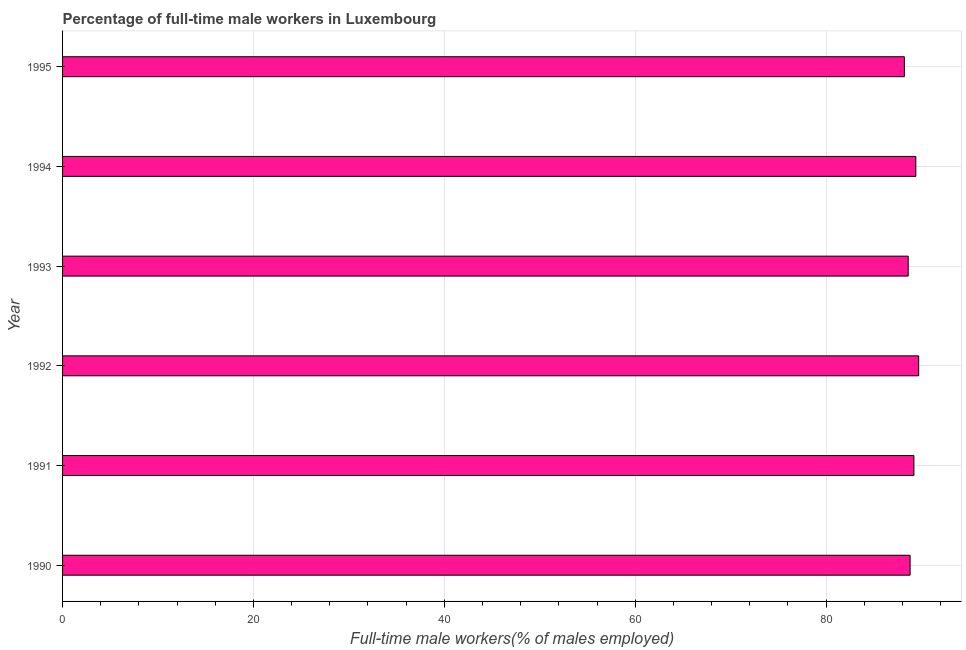Does the graph contain any zero values?
Keep it short and to the point. No. What is the title of the graph?
Offer a terse response. Percentage of full-time male workers in Luxembourg. What is the label or title of the X-axis?
Your response must be concise. Full-time male workers(% of males employed). What is the label or title of the Y-axis?
Give a very brief answer. Year. What is the percentage of full-time male workers in 1993?
Provide a short and direct response. 88.6. Across all years, what is the maximum percentage of full-time male workers?
Your response must be concise. 89.7. Across all years, what is the minimum percentage of full-time male workers?
Your answer should be compact. 88.2. In which year was the percentage of full-time male workers maximum?
Offer a terse response. 1992. What is the sum of the percentage of full-time male workers?
Provide a succinct answer. 533.9. What is the difference between the percentage of full-time male workers in 1990 and 1992?
Ensure brevity in your answer.  -0.9. What is the average percentage of full-time male workers per year?
Provide a short and direct response. 88.98. What is the median percentage of full-time male workers?
Your answer should be very brief. 89. In how many years, is the percentage of full-time male workers greater than 56 %?
Offer a terse response. 6. Do a majority of the years between 1995 and 1994 (inclusive) have percentage of full-time male workers greater than 64 %?
Make the answer very short. No. What is the ratio of the percentage of full-time male workers in 1990 to that in 1992?
Your response must be concise. 0.99. Is the percentage of full-time male workers in 1992 less than that in 1995?
Keep it short and to the point. No. Is the sum of the percentage of full-time male workers in 1990 and 1994 greater than the maximum percentage of full-time male workers across all years?
Your answer should be compact. Yes. What is the difference between the highest and the lowest percentage of full-time male workers?
Offer a terse response. 1.5. In how many years, is the percentage of full-time male workers greater than the average percentage of full-time male workers taken over all years?
Offer a very short reply. 3. What is the difference between two consecutive major ticks on the X-axis?
Give a very brief answer. 20. Are the values on the major ticks of X-axis written in scientific E-notation?
Your answer should be compact. No. What is the Full-time male workers(% of males employed) in 1990?
Make the answer very short. 88.8. What is the Full-time male workers(% of males employed) of 1991?
Your answer should be compact. 89.2. What is the Full-time male workers(% of males employed) of 1992?
Give a very brief answer. 89.7. What is the Full-time male workers(% of males employed) of 1993?
Your response must be concise. 88.6. What is the Full-time male workers(% of males employed) of 1994?
Offer a very short reply. 89.4. What is the Full-time male workers(% of males employed) in 1995?
Keep it short and to the point. 88.2. What is the difference between the Full-time male workers(% of males employed) in 1990 and 1991?
Give a very brief answer. -0.4. What is the difference between the Full-time male workers(% of males employed) in 1990 and 1992?
Give a very brief answer. -0.9. What is the difference between the Full-time male workers(% of males employed) in 1990 and 1994?
Make the answer very short. -0.6. What is the difference between the Full-time male workers(% of males employed) in 1990 and 1995?
Provide a short and direct response. 0.6. What is the difference between the Full-time male workers(% of males employed) in 1991 and 1992?
Provide a short and direct response. -0.5. What is the difference between the Full-time male workers(% of males employed) in 1991 and 1994?
Provide a succinct answer. -0.2. What is the difference between the Full-time male workers(% of males employed) in 1992 and 1994?
Your answer should be very brief. 0.3. What is the ratio of the Full-time male workers(% of males employed) in 1990 to that in 1992?
Offer a very short reply. 0.99. What is the ratio of the Full-time male workers(% of males employed) in 1990 to that in 1995?
Ensure brevity in your answer.  1.01. What is the ratio of the Full-time male workers(% of males employed) in 1992 to that in 1993?
Your response must be concise. 1.01. What is the ratio of the Full-time male workers(% of males employed) in 1992 to that in 1994?
Offer a terse response. 1. What is the ratio of the Full-time male workers(% of males employed) in 1992 to that in 1995?
Give a very brief answer. 1.02. What is the ratio of the Full-time male workers(% of males employed) in 1993 to that in 1994?
Offer a very short reply. 0.99. What is the ratio of the Full-time male workers(% of males employed) in 1993 to that in 1995?
Your answer should be compact. 1. 